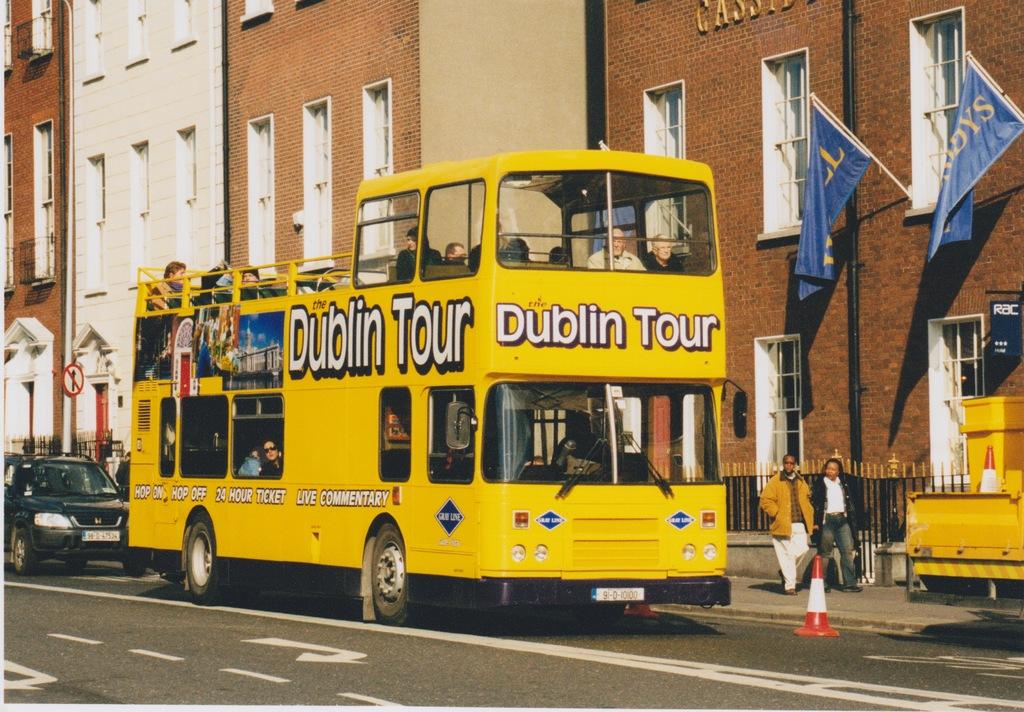Where is the bus going?
Keep it short and to the point. Dublin. What does the bus say is live?
Provide a short and direct response. Commentary. 